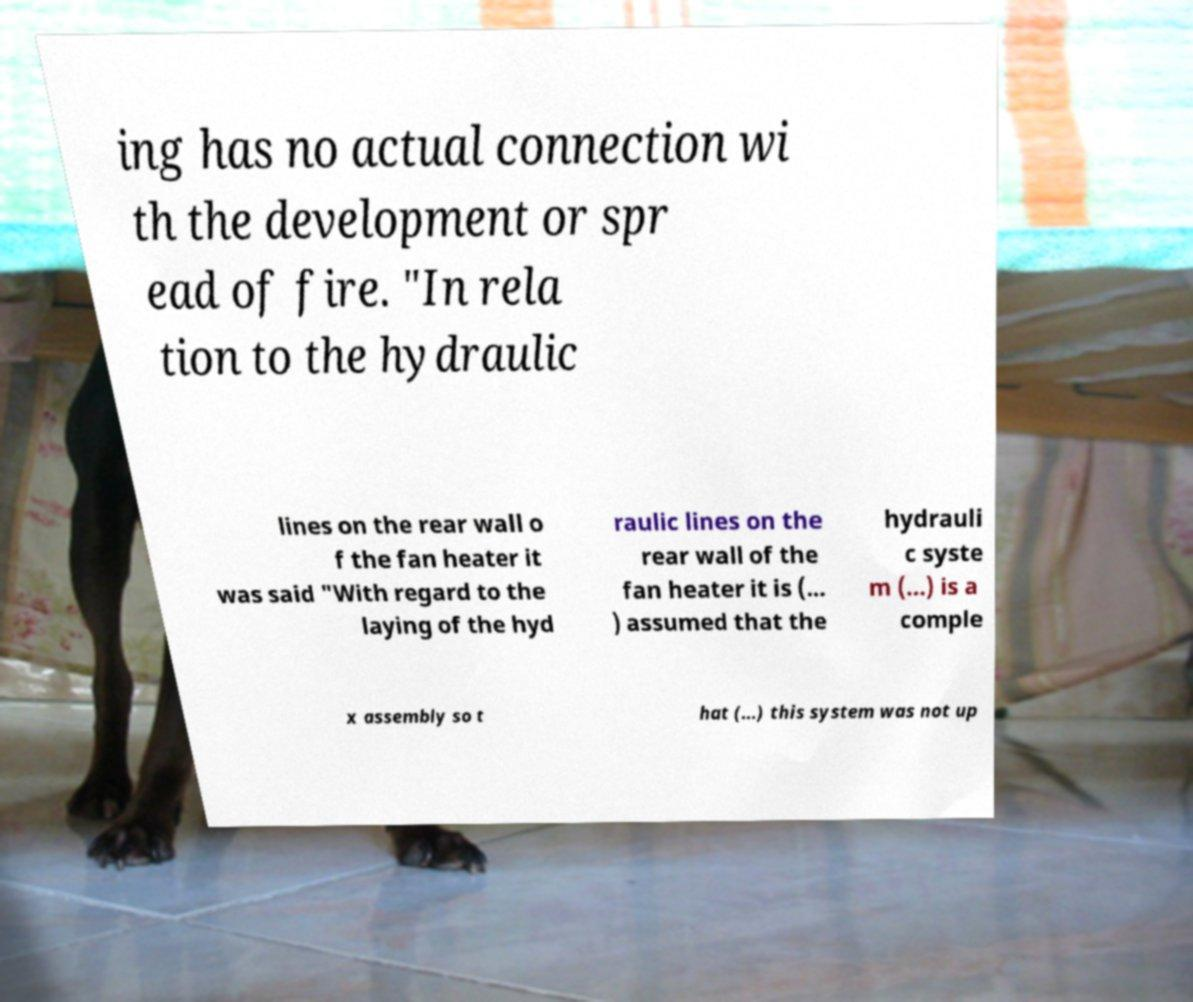Please read and relay the text visible in this image. What does it say? ing has no actual connection wi th the development or spr ead of fire. "In rela tion to the hydraulic lines on the rear wall o f the fan heater it was said "With regard to the laying of the hyd raulic lines on the rear wall of the fan heater it is (... ) assumed that the hydrauli c syste m (...) is a comple x assembly so t hat (...) this system was not up 